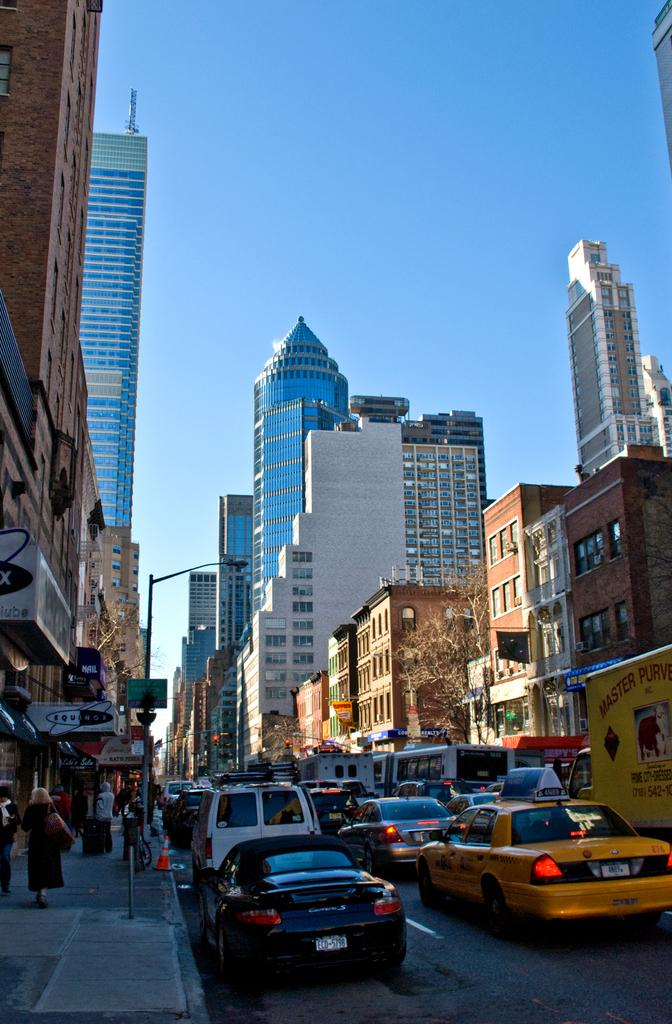<image>
Summarize the visual content of the image. A traffic jam in the city has a yellow truck in it that says Master Purve. 